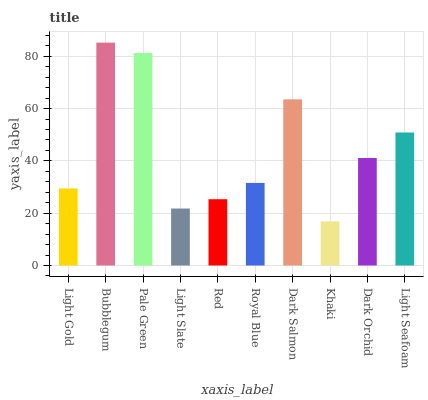Is Khaki the minimum?
Answer yes or no. Yes. Is Bubblegum the maximum?
Answer yes or no. Yes. Is Pale Green the minimum?
Answer yes or no. No. Is Pale Green the maximum?
Answer yes or no. No. Is Bubblegum greater than Pale Green?
Answer yes or no. Yes. Is Pale Green less than Bubblegum?
Answer yes or no. Yes. Is Pale Green greater than Bubblegum?
Answer yes or no. No. Is Bubblegum less than Pale Green?
Answer yes or no. No. Is Dark Orchid the high median?
Answer yes or no. Yes. Is Royal Blue the low median?
Answer yes or no. Yes. Is Red the high median?
Answer yes or no. No. Is Light Gold the low median?
Answer yes or no. No. 